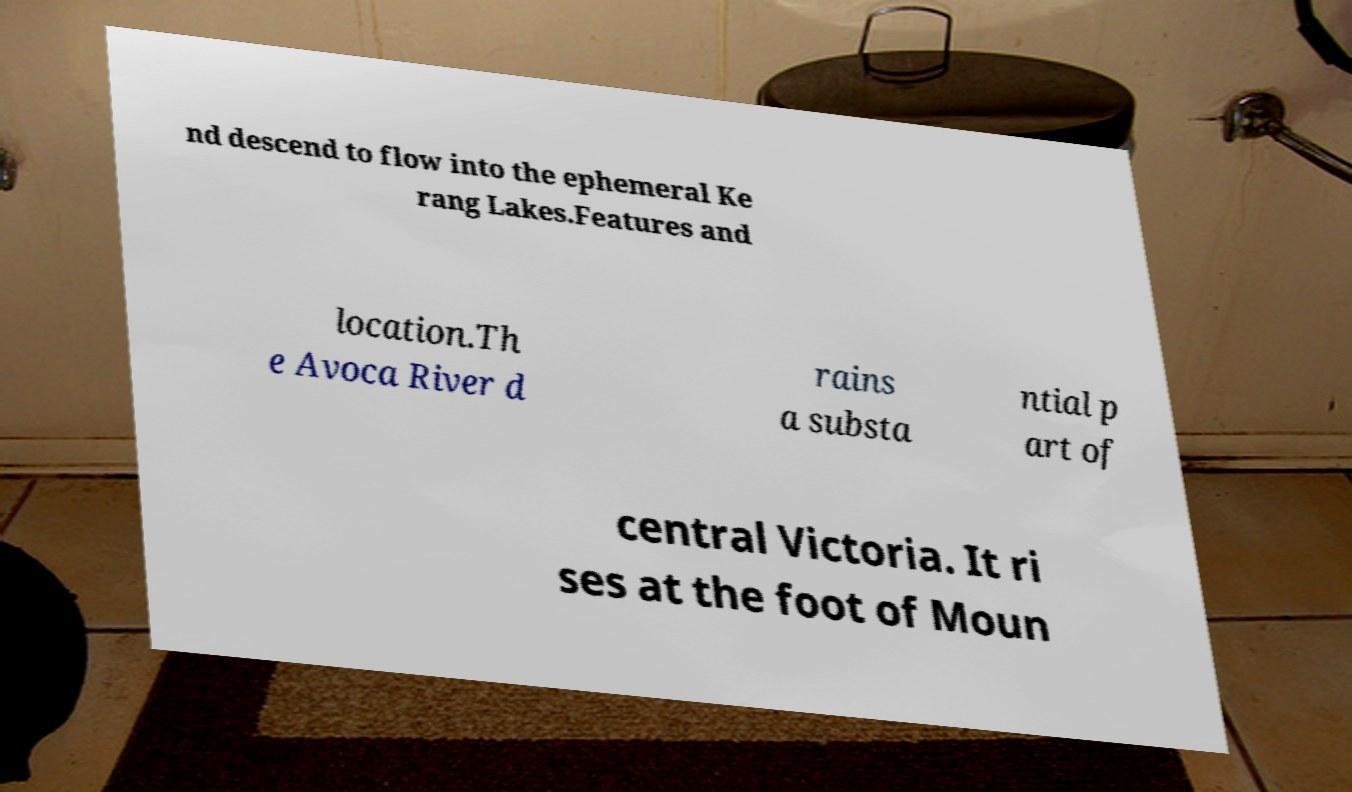Can you accurately transcribe the text from the provided image for me? nd descend to flow into the ephemeral Ke rang Lakes.Features and location.Th e Avoca River d rains a substa ntial p art of central Victoria. It ri ses at the foot of Moun 